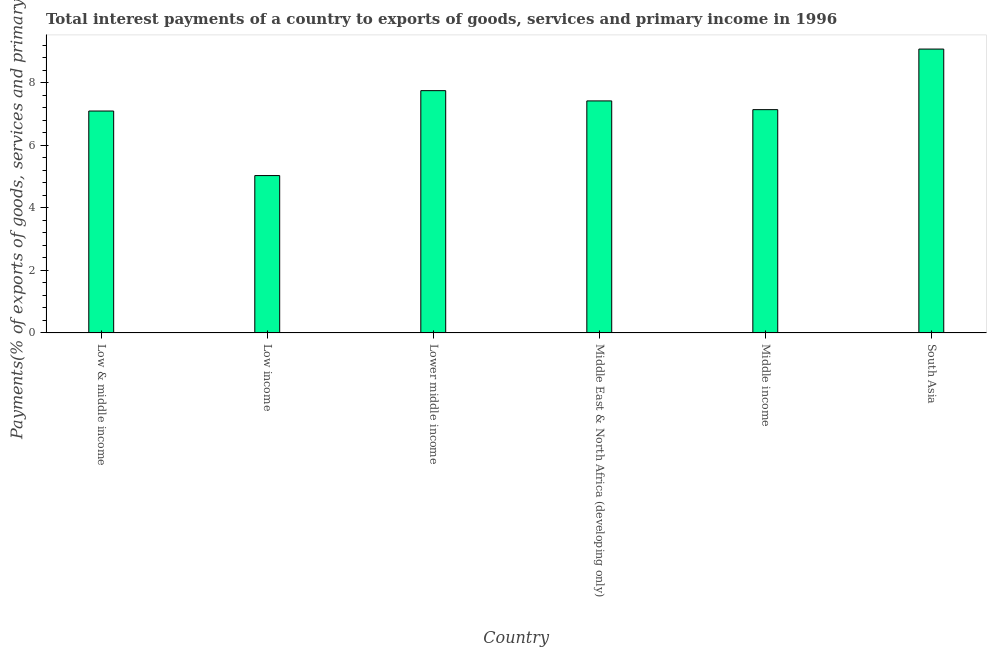What is the title of the graph?
Give a very brief answer. Total interest payments of a country to exports of goods, services and primary income in 1996. What is the label or title of the X-axis?
Make the answer very short. Country. What is the label or title of the Y-axis?
Keep it short and to the point. Payments(% of exports of goods, services and primary income). What is the total interest payments on external debt in Middle East & North Africa (developing only)?
Make the answer very short. 7.42. Across all countries, what is the maximum total interest payments on external debt?
Give a very brief answer. 9.08. Across all countries, what is the minimum total interest payments on external debt?
Ensure brevity in your answer.  5.04. In which country was the total interest payments on external debt maximum?
Offer a terse response. South Asia. What is the sum of the total interest payments on external debt?
Make the answer very short. 43.54. What is the difference between the total interest payments on external debt in Lower middle income and South Asia?
Offer a very short reply. -1.33. What is the average total interest payments on external debt per country?
Provide a succinct answer. 7.26. What is the median total interest payments on external debt?
Offer a very short reply. 7.28. In how many countries, is the total interest payments on external debt greater than 8.4 %?
Your answer should be compact. 1. What is the ratio of the total interest payments on external debt in Low income to that in South Asia?
Make the answer very short. 0.55. Is the difference between the total interest payments on external debt in Low income and Middle East & North Africa (developing only) greater than the difference between any two countries?
Ensure brevity in your answer.  No. What is the difference between the highest and the second highest total interest payments on external debt?
Your response must be concise. 1.33. Is the sum of the total interest payments on external debt in Low income and Middle income greater than the maximum total interest payments on external debt across all countries?
Provide a succinct answer. Yes. What is the difference between the highest and the lowest total interest payments on external debt?
Give a very brief answer. 4.05. In how many countries, is the total interest payments on external debt greater than the average total interest payments on external debt taken over all countries?
Offer a terse response. 3. Are all the bars in the graph horizontal?
Ensure brevity in your answer.  No. What is the difference between two consecutive major ticks on the Y-axis?
Keep it short and to the point. 2. Are the values on the major ticks of Y-axis written in scientific E-notation?
Give a very brief answer. No. What is the Payments(% of exports of goods, services and primary income) of Low & middle income?
Offer a terse response. 7.1. What is the Payments(% of exports of goods, services and primary income) in Low income?
Keep it short and to the point. 5.04. What is the Payments(% of exports of goods, services and primary income) in Lower middle income?
Give a very brief answer. 7.75. What is the Payments(% of exports of goods, services and primary income) in Middle East & North Africa (developing only)?
Ensure brevity in your answer.  7.42. What is the Payments(% of exports of goods, services and primary income) in Middle income?
Keep it short and to the point. 7.14. What is the Payments(% of exports of goods, services and primary income) of South Asia?
Make the answer very short. 9.08. What is the difference between the Payments(% of exports of goods, services and primary income) in Low & middle income and Low income?
Your response must be concise. 2.07. What is the difference between the Payments(% of exports of goods, services and primary income) in Low & middle income and Lower middle income?
Your answer should be compact. -0.65. What is the difference between the Payments(% of exports of goods, services and primary income) in Low & middle income and Middle East & North Africa (developing only)?
Your response must be concise. -0.32. What is the difference between the Payments(% of exports of goods, services and primary income) in Low & middle income and Middle income?
Your answer should be compact. -0.04. What is the difference between the Payments(% of exports of goods, services and primary income) in Low & middle income and South Asia?
Offer a terse response. -1.98. What is the difference between the Payments(% of exports of goods, services and primary income) in Low income and Lower middle income?
Your response must be concise. -2.72. What is the difference between the Payments(% of exports of goods, services and primary income) in Low income and Middle East & North Africa (developing only)?
Ensure brevity in your answer.  -2.39. What is the difference between the Payments(% of exports of goods, services and primary income) in Low income and Middle income?
Provide a succinct answer. -2.11. What is the difference between the Payments(% of exports of goods, services and primary income) in Low income and South Asia?
Provide a succinct answer. -4.05. What is the difference between the Payments(% of exports of goods, services and primary income) in Lower middle income and Middle East & North Africa (developing only)?
Offer a terse response. 0.33. What is the difference between the Payments(% of exports of goods, services and primary income) in Lower middle income and Middle income?
Give a very brief answer. 0.61. What is the difference between the Payments(% of exports of goods, services and primary income) in Lower middle income and South Asia?
Make the answer very short. -1.33. What is the difference between the Payments(% of exports of goods, services and primary income) in Middle East & North Africa (developing only) and Middle income?
Keep it short and to the point. 0.28. What is the difference between the Payments(% of exports of goods, services and primary income) in Middle East & North Africa (developing only) and South Asia?
Your answer should be compact. -1.66. What is the difference between the Payments(% of exports of goods, services and primary income) in Middle income and South Asia?
Make the answer very short. -1.94. What is the ratio of the Payments(% of exports of goods, services and primary income) in Low & middle income to that in Low income?
Offer a terse response. 1.41. What is the ratio of the Payments(% of exports of goods, services and primary income) in Low & middle income to that in Lower middle income?
Provide a succinct answer. 0.92. What is the ratio of the Payments(% of exports of goods, services and primary income) in Low & middle income to that in Middle East & North Africa (developing only)?
Ensure brevity in your answer.  0.96. What is the ratio of the Payments(% of exports of goods, services and primary income) in Low & middle income to that in Middle income?
Offer a very short reply. 0.99. What is the ratio of the Payments(% of exports of goods, services and primary income) in Low & middle income to that in South Asia?
Keep it short and to the point. 0.78. What is the ratio of the Payments(% of exports of goods, services and primary income) in Low income to that in Lower middle income?
Offer a terse response. 0.65. What is the ratio of the Payments(% of exports of goods, services and primary income) in Low income to that in Middle East & North Africa (developing only)?
Provide a succinct answer. 0.68. What is the ratio of the Payments(% of exports of goods, services and primary income) in Low income to that in Middle income?
Your answer should be very brief. 0.7. What is the ratio of the Payments(% of exports of goods, services and primary income) in Low income to that in South Asia?
Make the answer very short. 0.55. What is the ratio of the Payments(% of exports of goods, services and primary income) in Lower middle income to that in Middle East & North Africa (developing only)?
Make the answer very short. 1.04. What is the ratio of the Payments(% of exports of goods, services and primary income) in Lower middle income to that in Middle income?
Keep it short and to the point. 1.08. What is the ratio of the Payments(% of exports of goods, services and primary income) in Lower middle income to that in South Asia?
Give a very brief answer. 0.85. What is the ratio of the Payments(% of exports of goods, services and primary income) in Middle East & North Africa (developing only) to that in Middle income?
Make the answer very short. 1.04. What is the ratio of the Payments(% of exports of goods, services and primary income) in Middle East & North Africa (developing only) to that in South Asia?
Keep it short and to the point. 0.82. What is the ratio of the Payments(% of exports of goods, services and primary income) in Middle income to that in South Asia?
Make the answer very short. 0.79. 